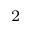<formula> <loc_0><loc_0><loc_500><loc_500>_ { 2 }</formula> 